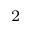<formula> <loc_0><loc_0><loc_500><loc_500>_ { 2 }</formula> 